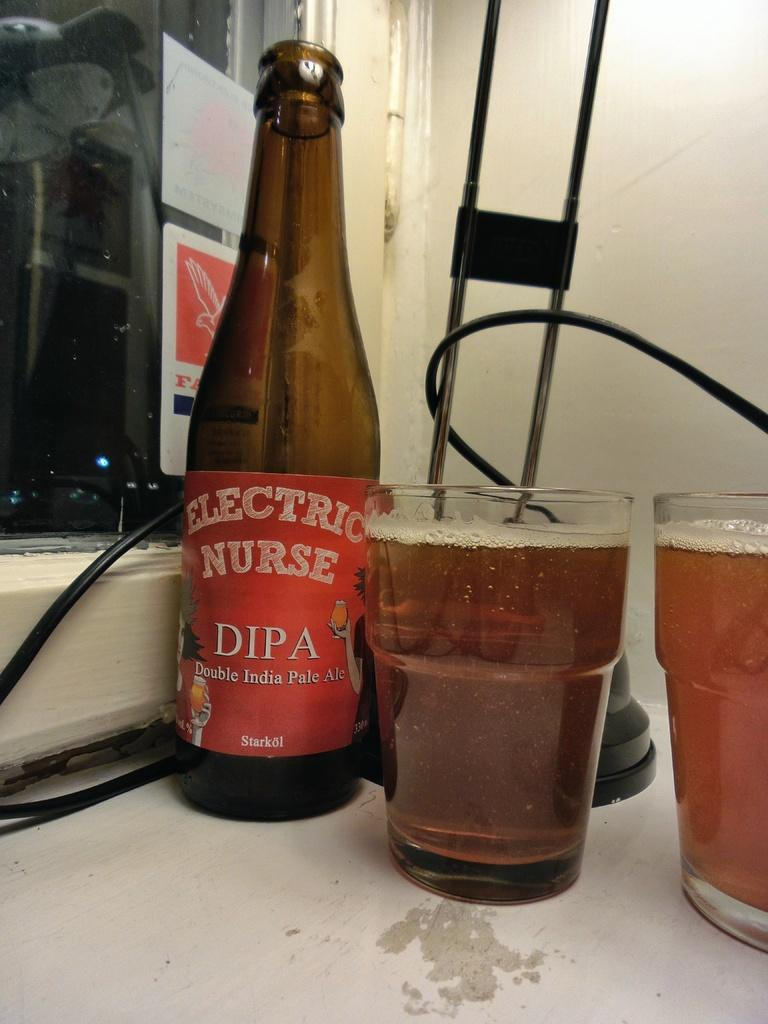<image>
Present a compact description of the photo's key features. A bottle with an Electric Nurse label is next to glasses that are full. 